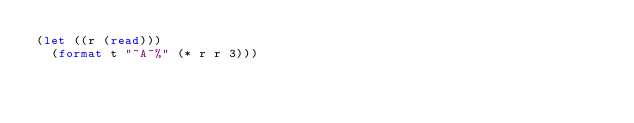<code> <loc_0><loc_0><loc_500><loc_500><_Lisp_>(let ((r (read)))
  (format t "~A~%" (* r r 3)))
</code> 